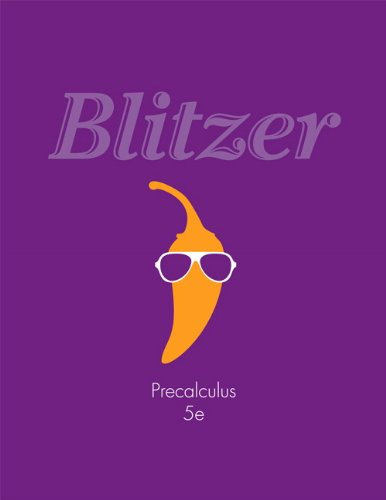What is the title of this book? The title of this scholarly book is 'Precalculus (5th Edition)', a popular resource among students for preparing them in mathematics before they embark on calculus courses. 